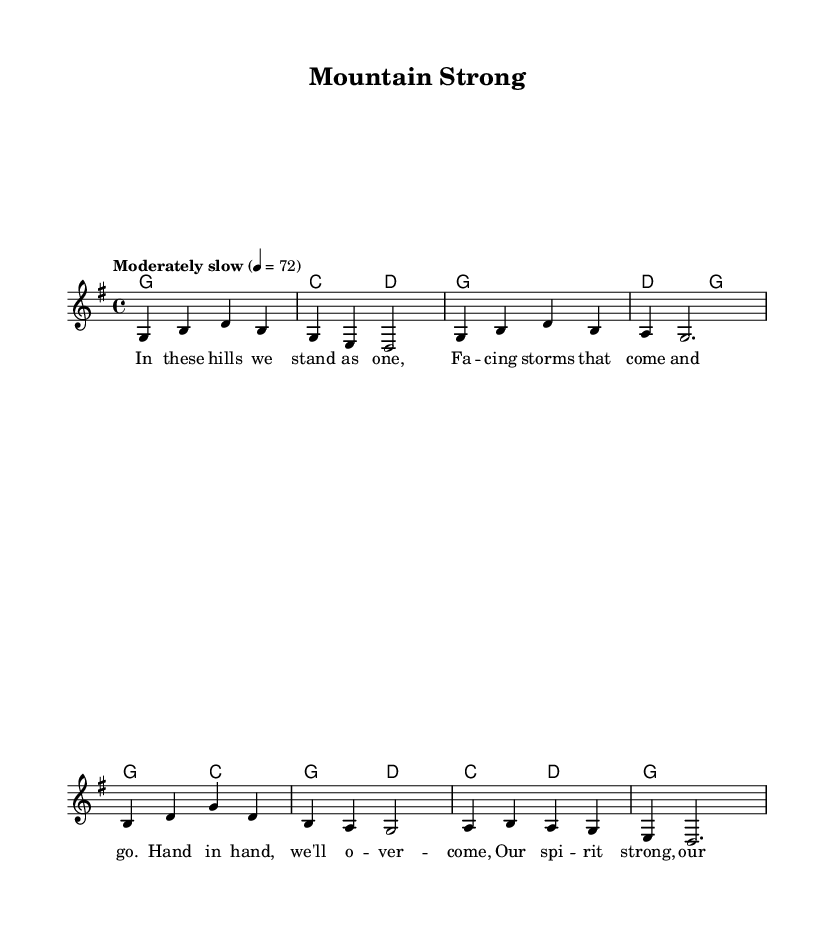What is the key signature of this music? The key signature is G major, which has one sharp, F#. This can be determined from the 'key g major' notation in the global variables section.
Answer: G major What is the time signature of this piece? The time signature is 4/4, as indicated by the 'time 4/4' notation in the global variables section. This means there are four beats in each measure.
Answer: 4/4 What is the tempo marking of this sheet music? The tempo marking is "Moderately slow" with a metronome marking of 72 beats per minute. This is specified in the 'tempo' line in the global section.
Answer: Moderately slow How many bars are in the melody? The melody consists of 8 bars. This can be counted by identifying each vertical line separating the measures in the melody section.
Answer: 8 What is the name of this song? The title of the song is "Mountain Strong," listed under the header section at the top of the sheet music.
Answer: Mountain Strong What theme does the lyrical content of this ballad convey? The theme conveys community resilience, as illustrated by phrases like "Hand in hand, we'll overcome" and "Our spirit strong." This is derived from the lyrics themselves, which emphasize unity in facing challenges.
Answer: Community resilience What instrument is primarily represented in this sheet music? The primary instrument represented is the voice, as indicated by the new Voice = "lead" notation, which shows that the melody is intended for vocal performance.
Answer: Voice 